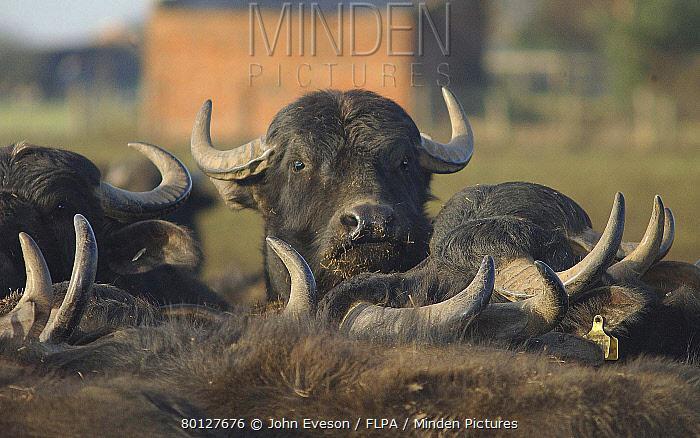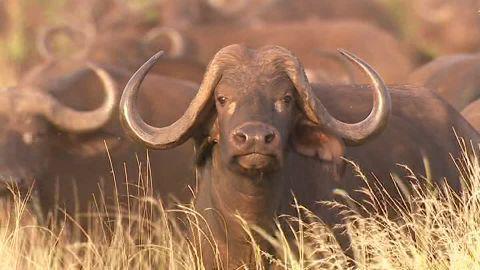The first image is the image on the left, the second image is the image on the right. Examine the images to the left and right. Is the description "The sky is visible in the left image." accurate? Answer yes or no. Yes. The first image is the image on the left, the second image is the image on the right. Analyze the images presented: Is the assertion "In each image, at least one forward-facing water buffalo with raised head is prominent, and no image contains more than a dozen distinguishable buffalo." valid? Answer yes or no. Yes. 